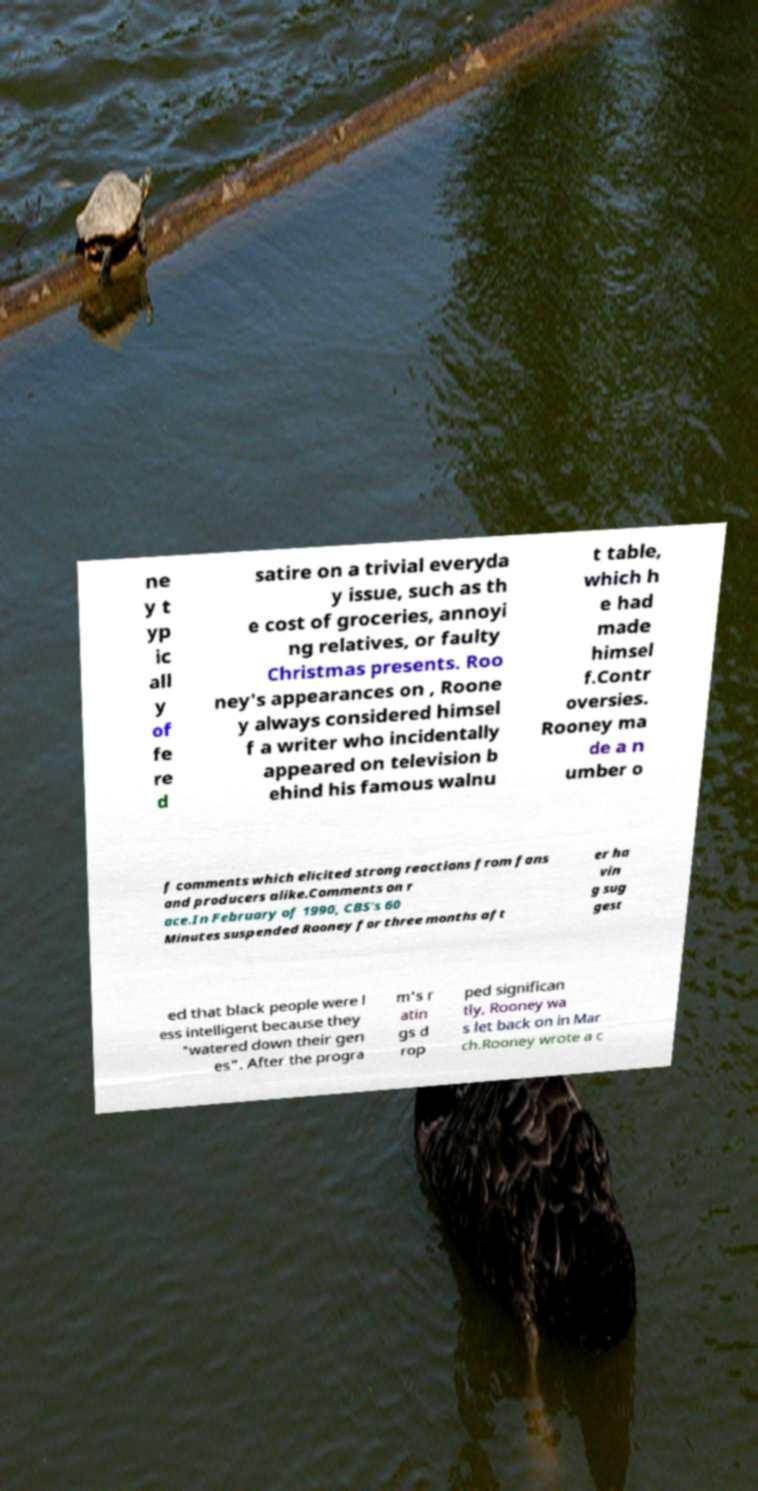I need the written content from this picture converted into text. Can you do that? ne y t yp ic all y of fe re d satire on a trivial everyda y issue, such as th e cost of groceries, annoyi ng relatives, or faulty Christmas presents. Roo ney's appearances on , Roone y always considered himsel f a writer who incidentally appeared on television b ehind his famous walnu t table, which h e had made himsel f.Contr oversies. Rooney ma de a n umber o f comments which elicited strong reactions from fans and producers alike.Comments on r ace.In February of 1990, CBS's 60 Minutes suspended Rooney for three months aft er ha vin g sug gest ed that black people were l ess intelligent because they "watered down their gen es". After the progra m's r atin gs d rop ped significan tly, Rooney wa s let back on in Mar ch.Rooney wrote a c 